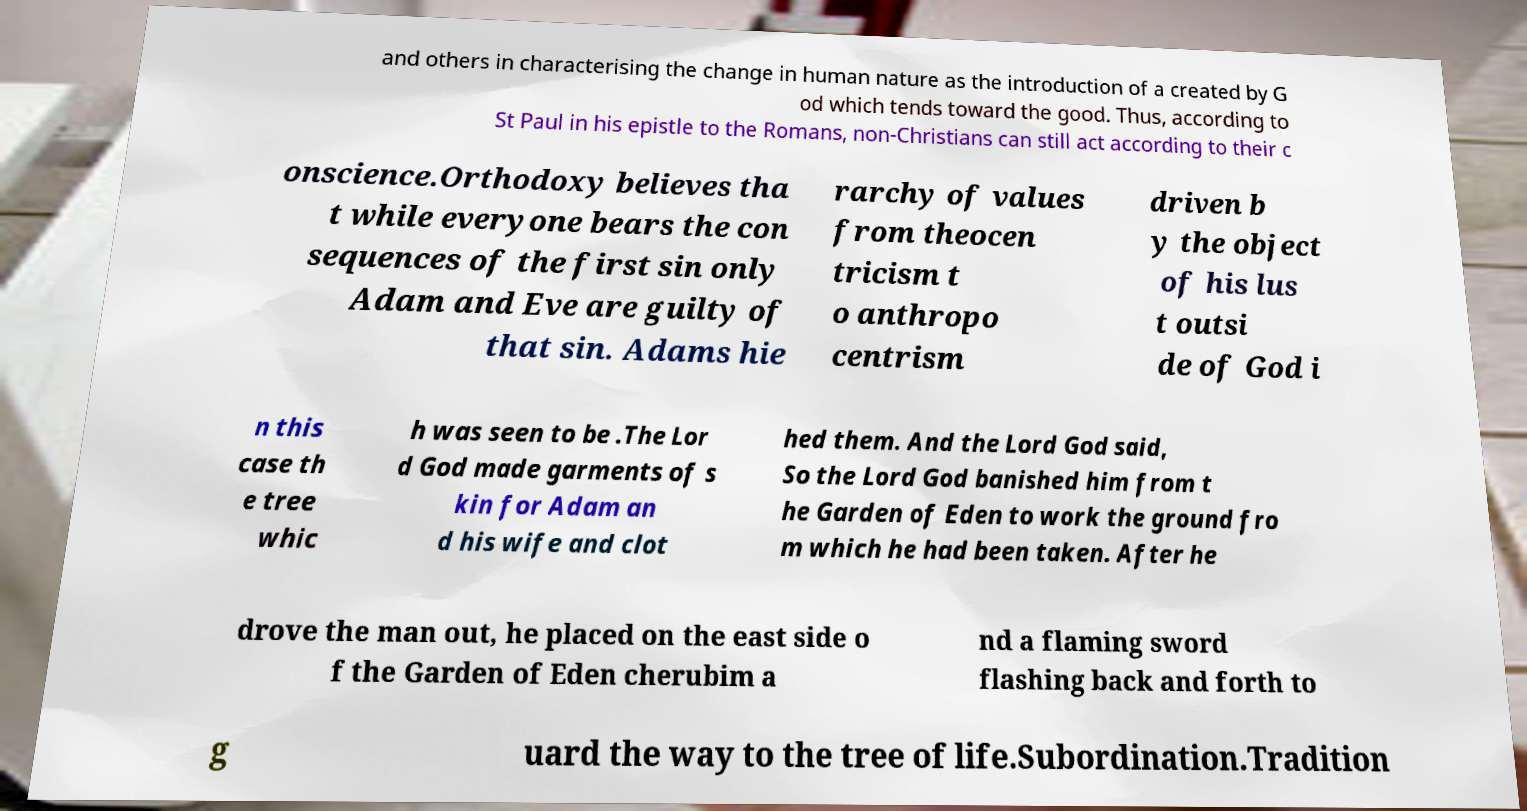For documentation purposes, I need the text within this image transcribed. Could you provide that? and others in characterising the change in human nature as the introduction of a created by G od which tends toward the good. Thus, according to St Paul in his epistle to the Romans, non-Christians can still act according to their c onscience.Orthodoxy believes tha t while everyone bears the con sequences of the first sin only Adam and Eve are guilty of that sin. Adams hie rarchy of values from theocen tricism t o anthropo centrism driven b y the object of his lus t outsi de of God i n this case th e tree whic h was seen to be .The Lor d God made garments of s kin for Adam an d his wife and clot hed them. And the Lord God said, So the Lord God banished him from t he Garden of Eden to work the ground fro m which he had been taken. After he drove the man out, he placed on the east side o f the Garden of Eden cherubim a nd a flaming sword flashing back and forth to g uard the way to the tree of life.Subordination.Tradition 